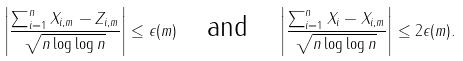Convert formula to latex. <formula><loc_0><loc_0><loc_500><loc_500>\left | \frac { \sum _ { i = 1 } ^ { n } X _ { i , m } - Z _ { i , m } } { \sqrt { n \log \log n } } \right | \leq \epsilon ( m ) \quad \text {and} \quad \left | \frac { \sum _ { i = 1 } ^ { n } X _ { i } - X _ { i , m } } { \sqrt { n \log \log n } } \right | \leq 2 \epsilon ( m ) .</formula> 